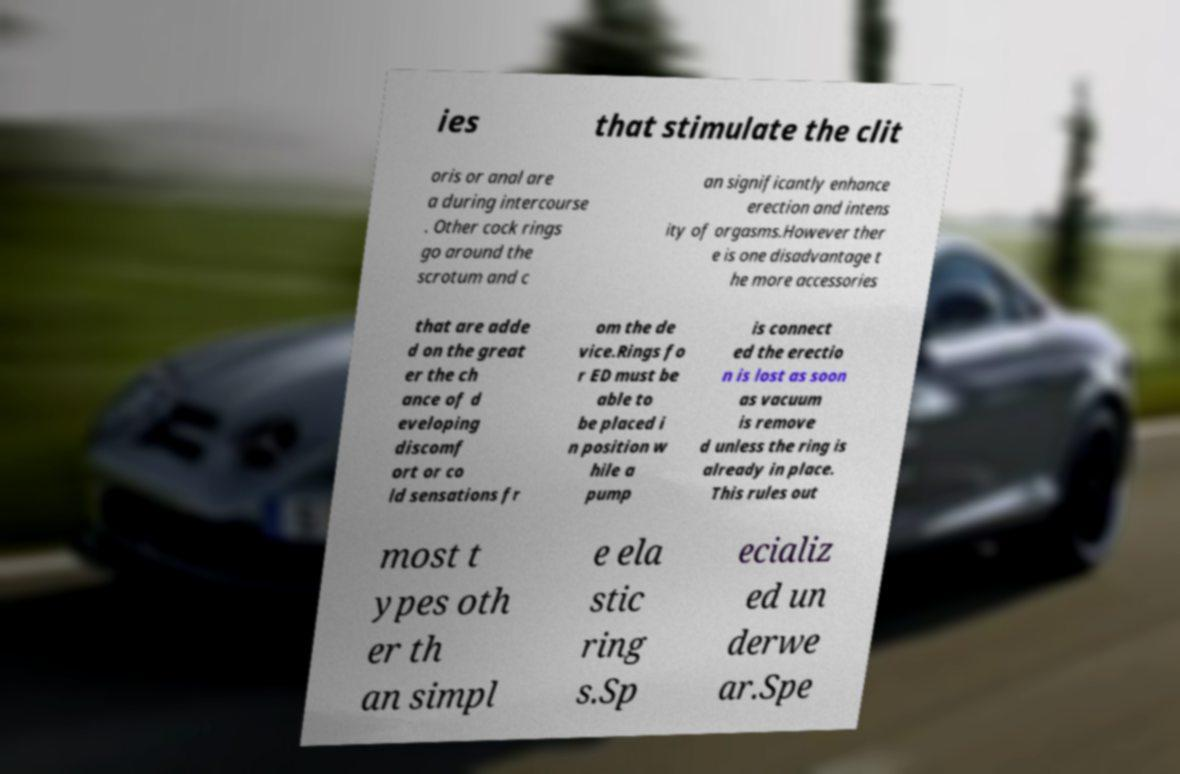Could you extract and type out the text from this image? ies that stimulate the clit oris or anal are a during intercourse . Other cock rings go around the scrotum and c an significantly enhance erection and intens ity of orgasms.However ther e is one disadvantage t he more accessories that are adde d on the great er the ch ance of d eveloping discomf ort or co ld sensations fr om the de vice.Rings fo r ED must be able to be placed i n position w hile a pump is connect ed the erectio n is lost as soon as vacuum is remove d unless the ring is already in place. This rules out most t ypes oth er th an simpl e ela stic ring s.Sp ecializ ed un derwe ar.Spe 